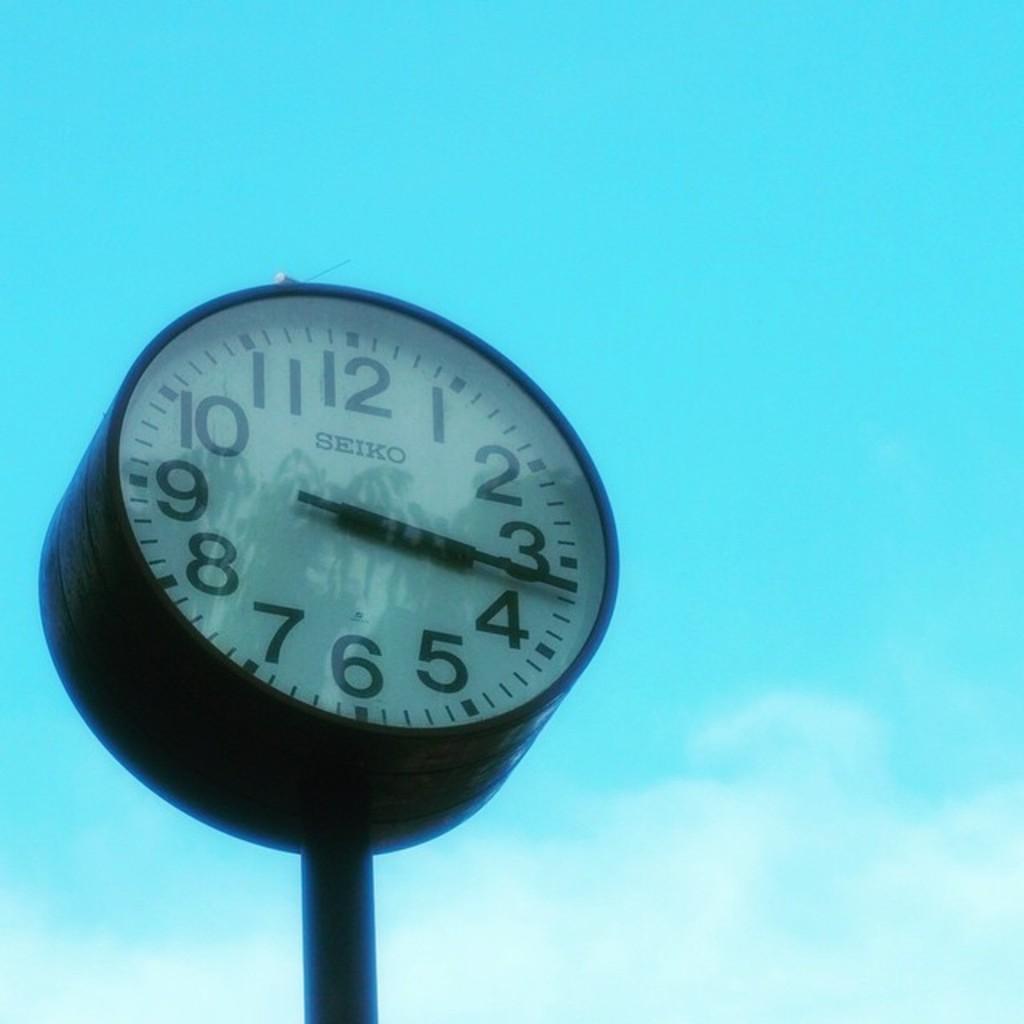How would you summarize this image in a sentence or two? In this image there is a clock. In the background there is the sky. 